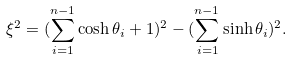Convert formula to latex. <formula><loc_0><loc_0><loc_500><loc_500>\xi ^ { 2 } = ( \sum _ { i = 1 } ^ { n - 1 } \cosh \theta _ { i } + 1 ) ^ { 2 } - ( \sum _ { i = 1 } ^ { n - 1 } \sinh \theta _ { i } ) ^ { 2 } .</formula> 